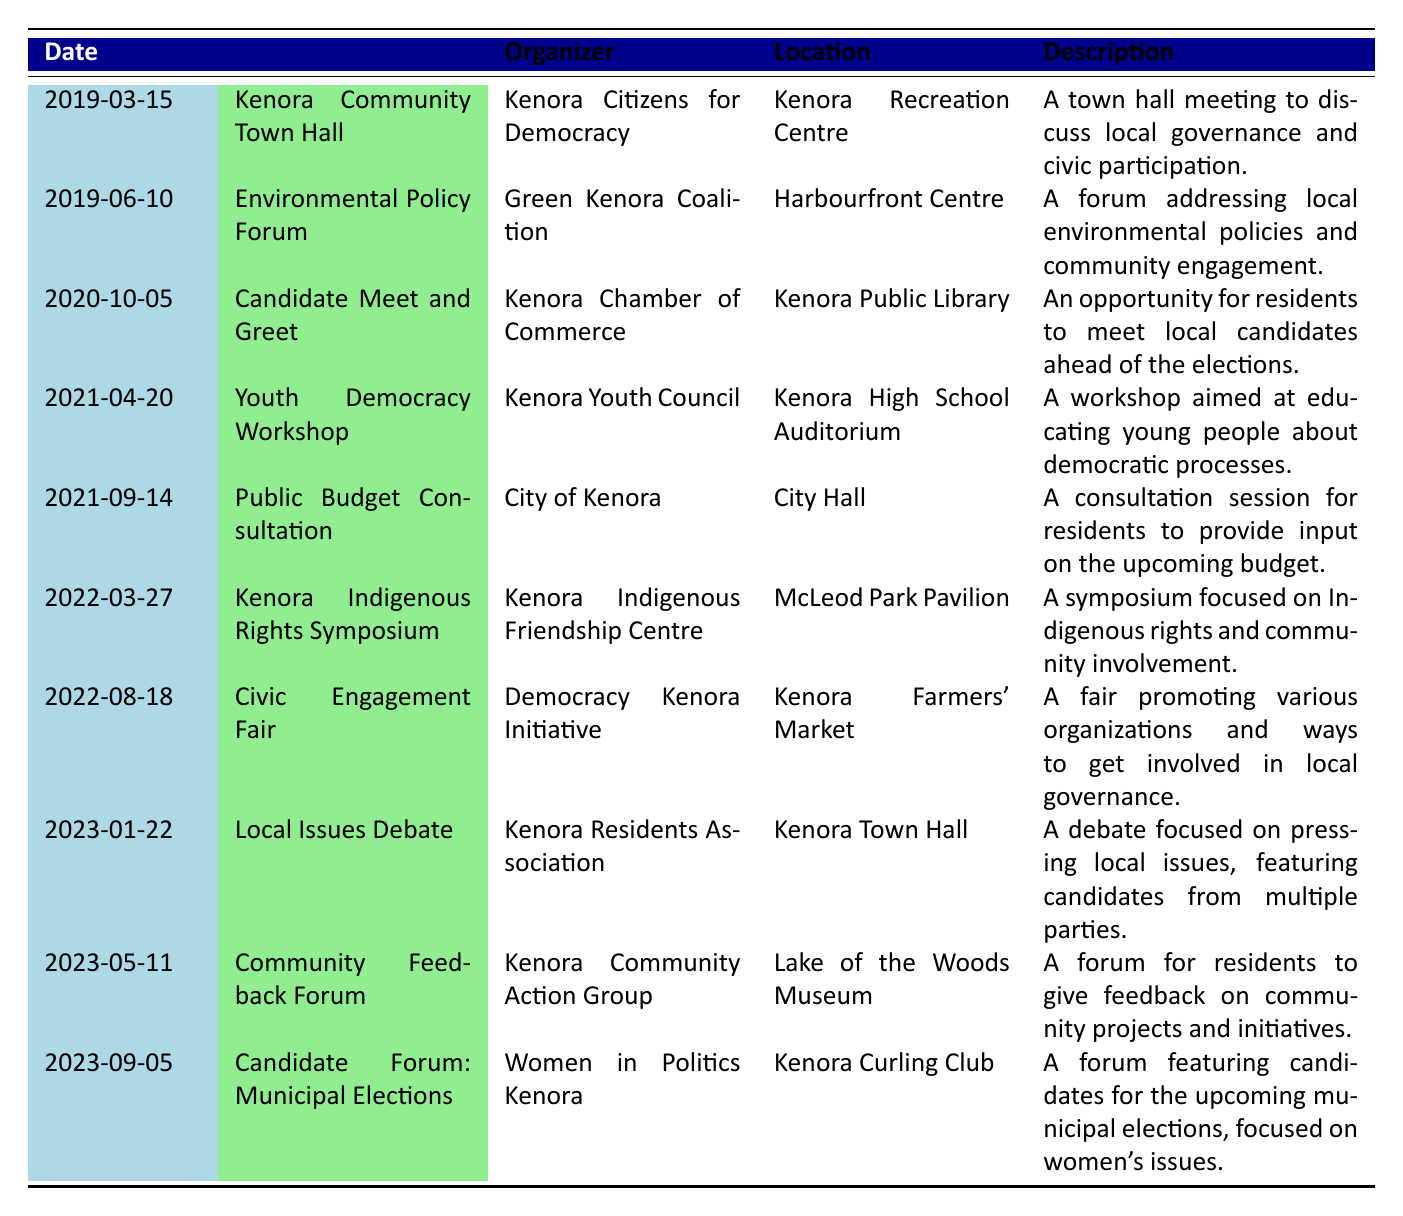What was the date of the Kenora Community Town Hall? The date provided in the table for the Kenora Community Town Hall event is 2019-03-15.
Answer: 2019-03-15 Which organization hosted the Civic Engagement Fair? The table indicates that the Civic Engagement Fair was organized by the Democracy Kenora Initiative.
Answer: Democracy Kenora Initiative How many events took place in 2023? By scanning the dates listed in the table, there are three events in the year 2023 (January 22, May 11, and September 5).
Answer: 3 Was there a Youth Democracy Workshop organized in 2021? Yes, the table lists a Youth Democracy Workshop organized by the Kenora Youth Council on April 20, 2021.
Answer: Yes Which event focused on Indigenous rights? The event that focused on Indigenous rights is the Kenora Indigenous Rights Symposium organized by the Kenora Indigenous Friendship Centre on March 27, 2022.
Answer: Kenora Indigenous Rights Symposium What is the difference in years between the first and the last events listed? The first event is from 2019 and the last event is from 2023. The difference in years is 2023 - 2019 = 4 years.
Answer: 4 years Which location hosted the Local Issues Debate? The table shows that the Local Issues Debate was held at the Kenora Town Hall.
Answer: Kenora Town Hall How many events were organized by the City of Kenora? There is one event organized by the City of Kenora listed in the table, which is the Public Budget Consultation on September 14, 2021.
Answer: 1 Which event had the longest duration between it and the next event? The table shows the events are chronologically listed. The longest duration is between the Environmental Policy Forum on June 10, 2019, and the Candidate Meet and Greet on October 5, 2020. The duration is 1 year and 4 months.
Answer: 1 year and 4 months 